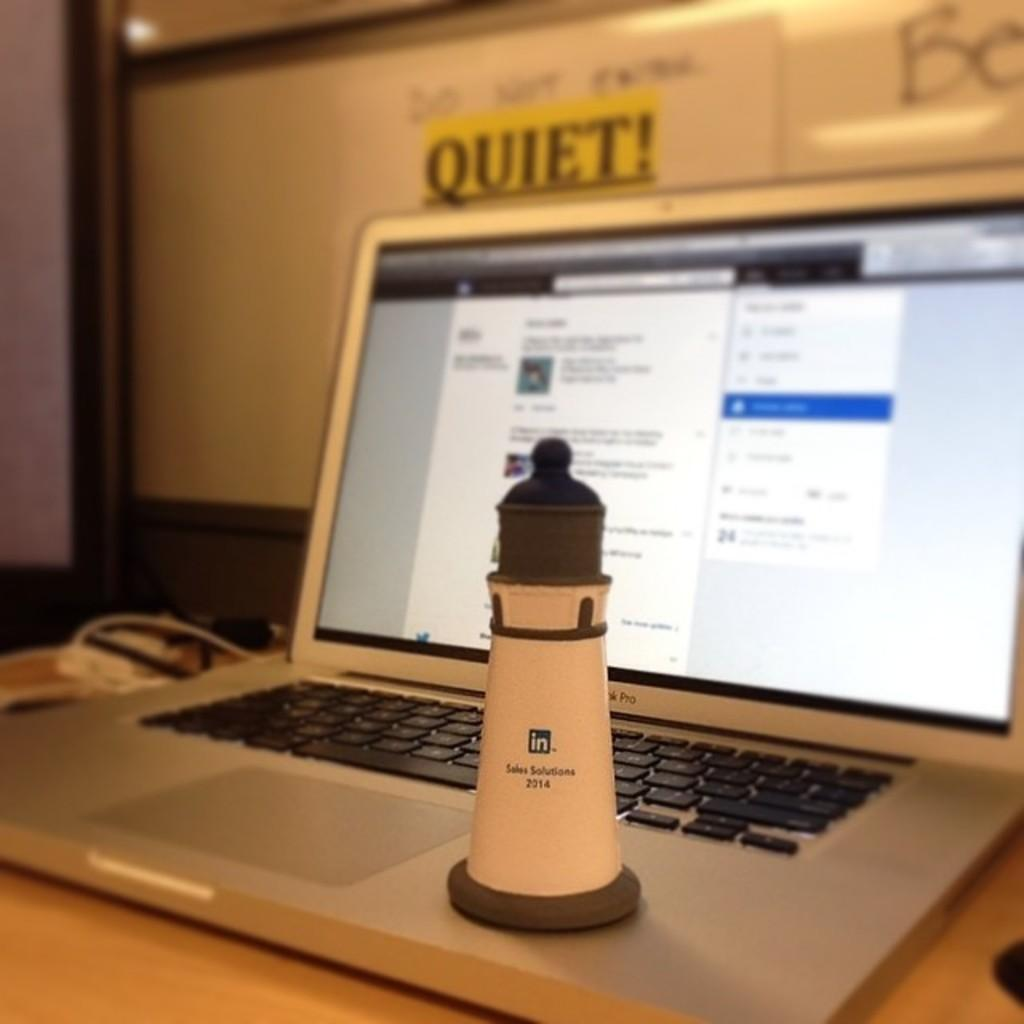<image>
Relay a brief, clear account of the picture shown. Small lighthouse with the words "Sales Solutions" on it on top of a laptop. 